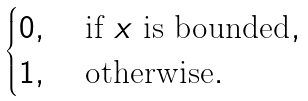<formula> <loc_0><loc_0><loc_500><loc_500>\begin{cases} 0 , & \text { if } x \text { is bounded} , \\ 1 , & \text { otherwise} . \end{cases}</formula> 